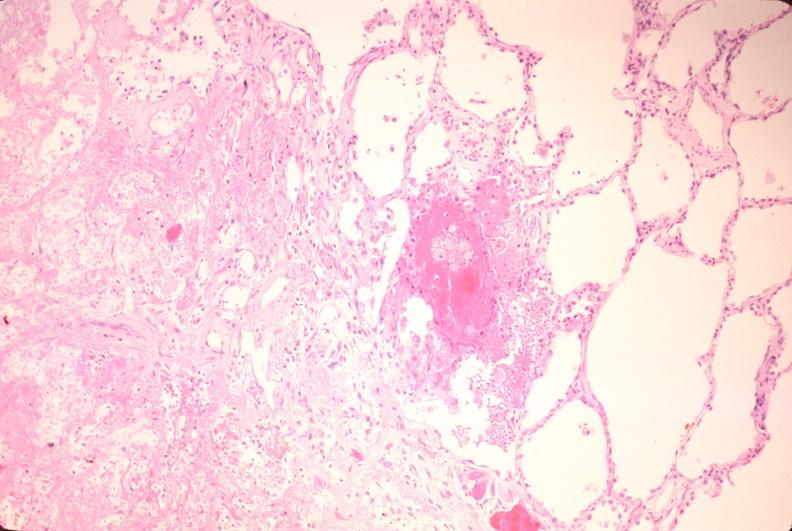what is present?
Answer the question using a single word or phrase. Respiratory 